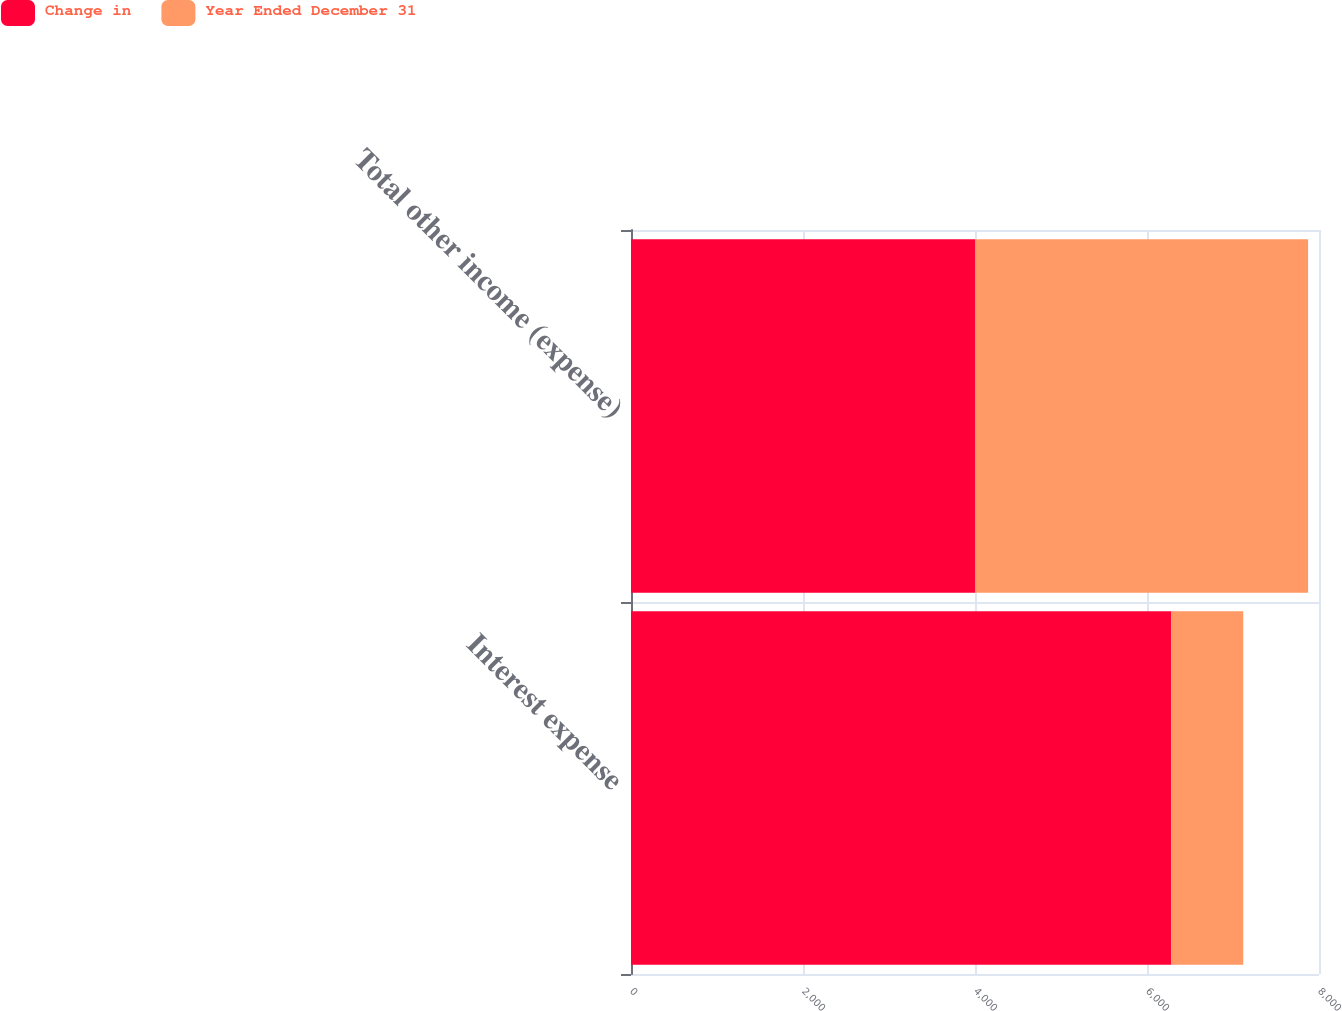<chart> <loc_0><loc_0><loc_500><loc_500><stacked_bar_chart><ecel><fcel>Interest expense<fcel>Total other income (expense)<nl><fcel>Change in<fcel>6280<fcel>4005<nl><fcel>Year Ended December 31<fcel>839<fcel>3868<nl></chart> 